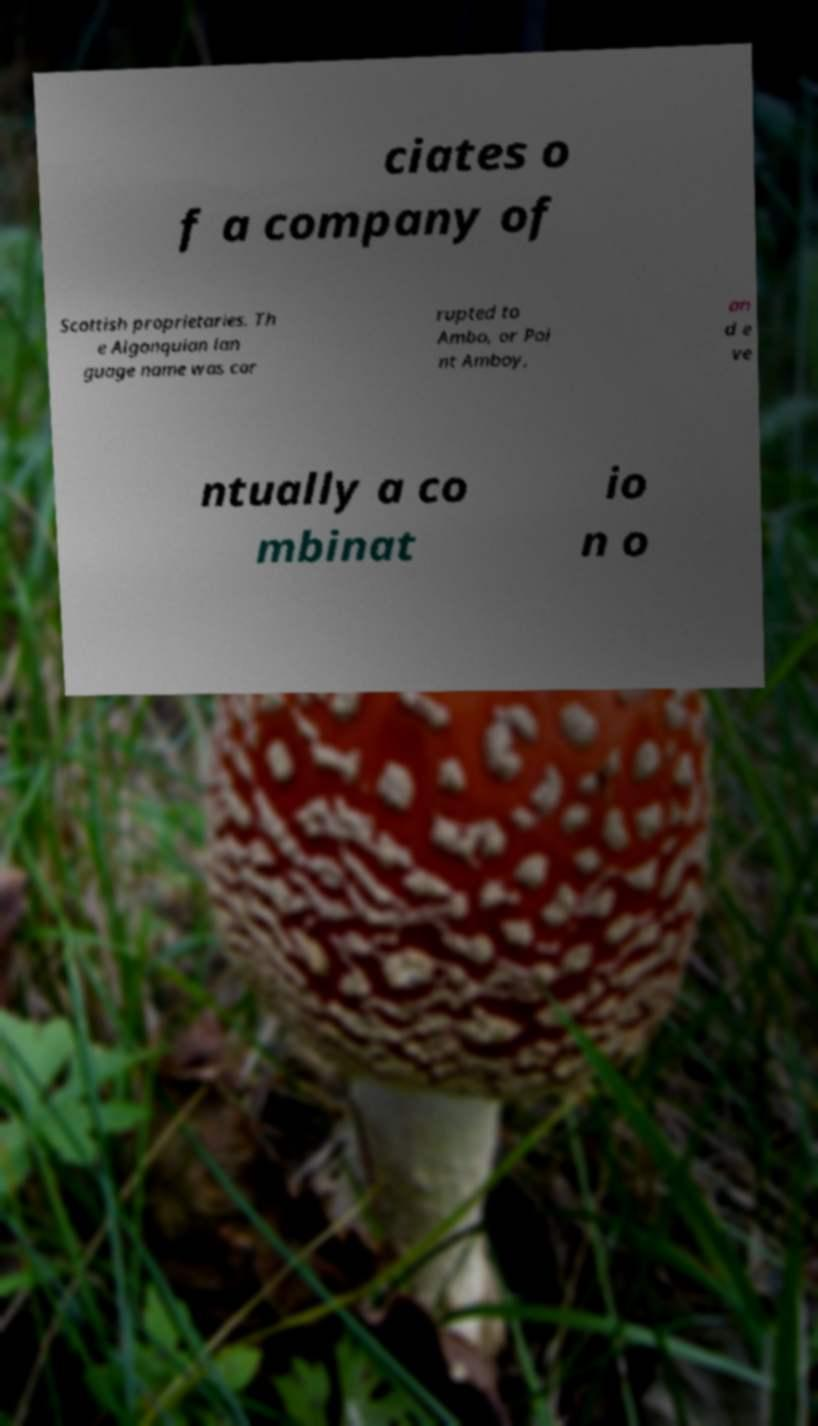Can you read and provide the text displayed in the image?This photo seems to have some interesting text. Can you extract and type it out for me? ciates o f a company of Scottish proprietaries. Th e Algonquian lan guage name was cor rupted to Ambo, or Poi nt Amboy, an d e ve ntually a co mbinat io n o 